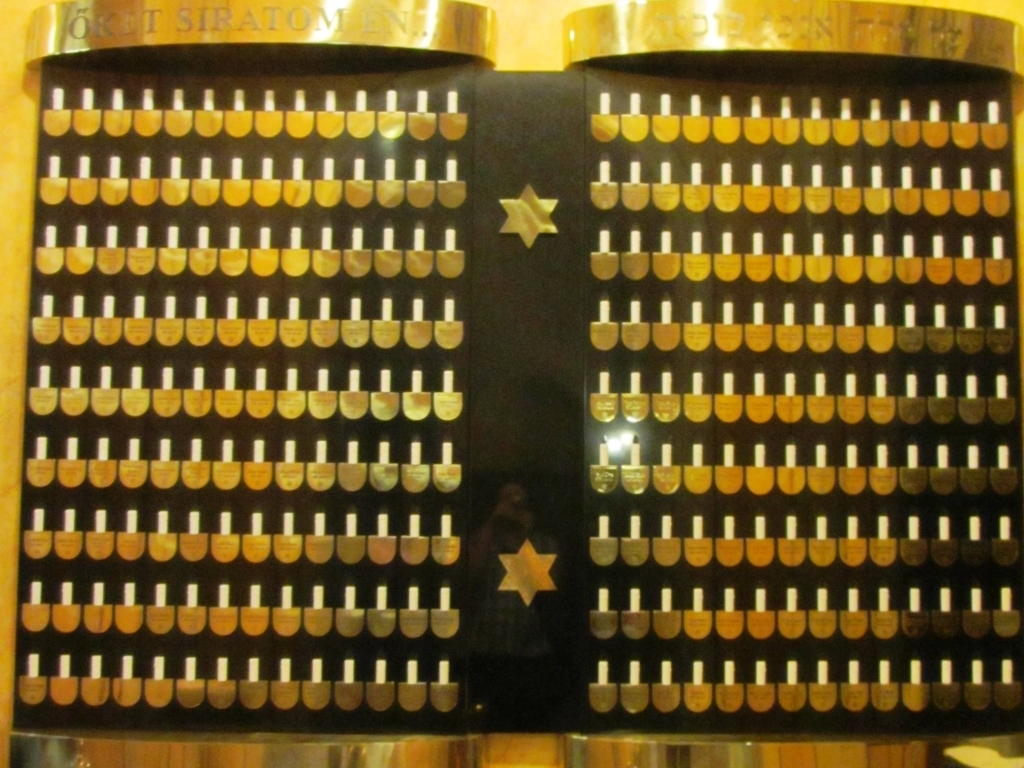Can you tell me what this object is used for? This appears to be a close-up of a historical mechanical calculator, often used for complex mathematical operations before the advent of electronic computers. Each cylindrical key represents different numbers or functions that would contribute to calculations. 